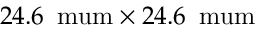Convert formula to latex. <formula><loc_0><loc_0><loc_500><loc_500>2 4 . 6 \, \ m u m \times 2 4 . 6 \, \ m u m</formula> 